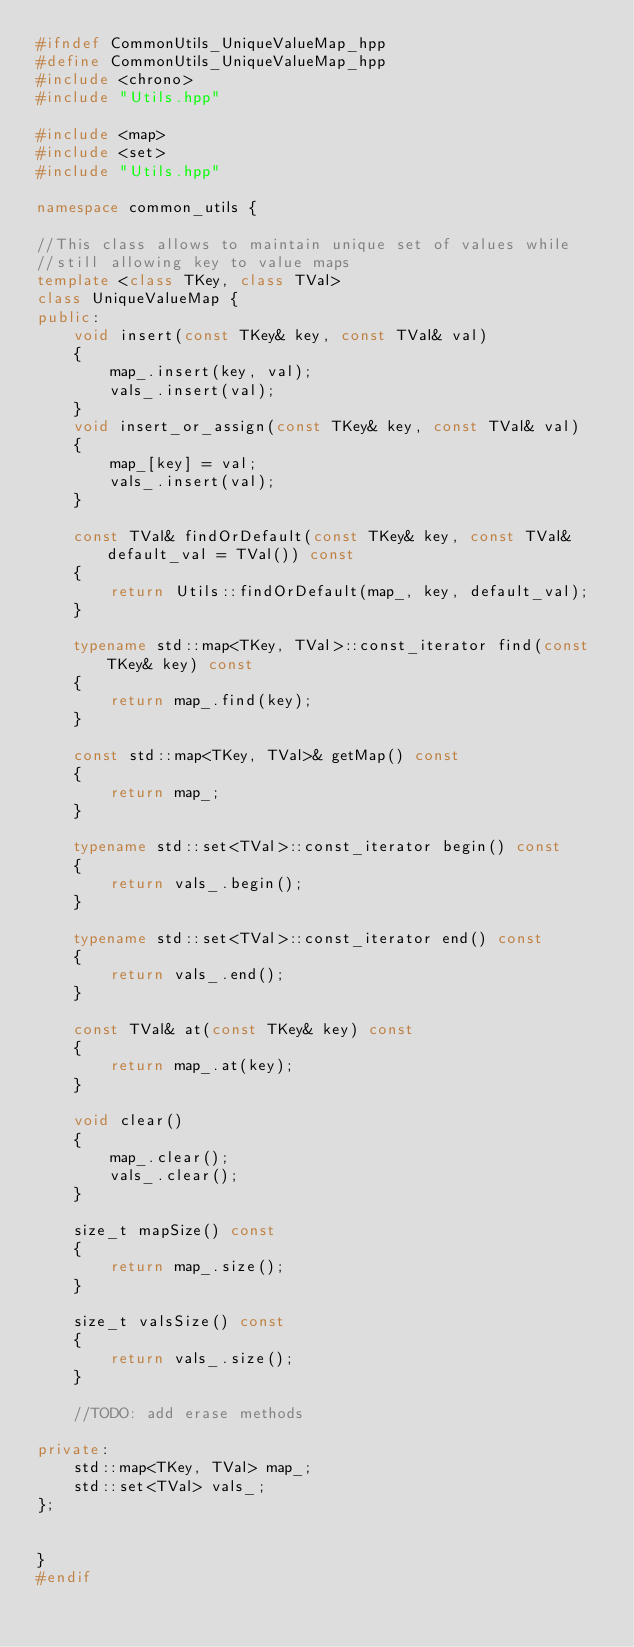<code> <loc_0><loc_0><loc_500><loc_500><_C++_>#ifndef CommonUtils_UniqueValueMap_hpp
#define CommonUtils_UniqueValueMap_hpp
#include <chrono>
#include "Utils.hpp"

#include <map>
#include <set>
#include "Utils.hpp"

namespace common_utils {

//This class allows to maintain unique set of values while 
//still allowing key to value maps
template <class TKey, class TVal>
class UniqueValueMap {
public:
    void insert(const TKey& key, const TVal& val)
    {
        map_.insert(key, val);
        vals_.insert(val);
    }
    void insert_or_assign(const TKey& key, const TVal& val)
    {
        map_[key] = val;
        vals_.insert(val);
    }

    const TVal& findOrDefault(const TKey& key, const TVal& default_val = TVal()) const
    {
        return Utils::findOrDefault(map_, key, default_val);
    }

    typename std::map<TKey, TVal>::const_iterator find(const TKey& key) const
    {
        return map_.find(key);
    }

    const std::map<TKey, TVal>& getMap() const
    {
        return map_;
    }

    typename std::set<TVal>::const_iterator begin() const
    {
        return vals_.begin();
    }

    typename std::set<TVal>::const_iterator end() const
    {
        return vals_.end();
    }

    const TVal& at(const TKey& key) const
    {
        return map_.at(key);
    }

    void clear()
    {
        map_.clear();
        vals_.clear();
    }

    size_t mapSize() const
    {
        return map_.size();
    }

    size_t valsSize() const
    {
        return vals_.size();
    }

    //TODO: add erase methods

private:
    std::map<TKey, TVal> map_;
    std::set<TVal> vals_;
};


}
#endif</code> 